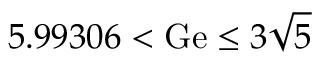Convert formula to latex. <formula><loc_0><loc_0><loc_500><loc_500>5 . 9 9 3 0 6 < G e \leq 3 \sqrt { 5 }</formula> 